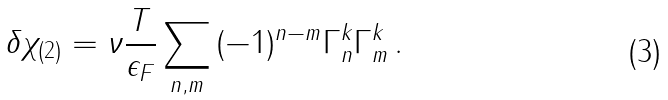Convert formula to latex. <formula><loc_0><loc_0><loc_500><loc_500>\, \delta \chi _ { ( 2 ) } = \nu \frac { T } { \epsilon _ { F } } \sum _ { n , m } { ( - 1 ) ^ { n - m } \Gamma _ { n } ^ { k } \Gamma _ { m } ^ { k } } \, .</formula> 